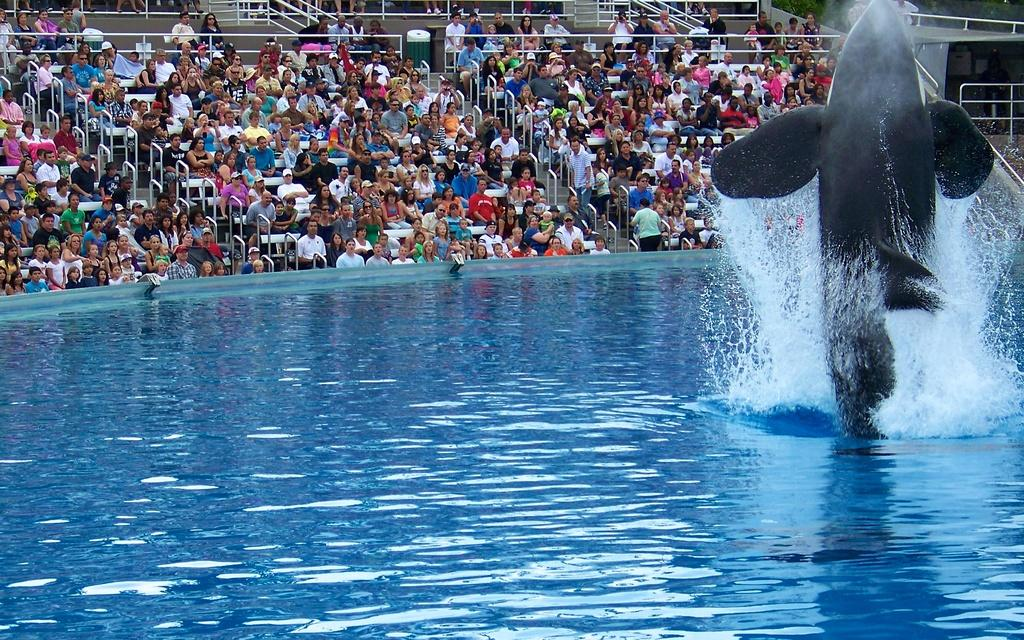What animal can be seen on the right side of the image? There is a dolphin on the right side of the image. What is present at the bottom of the image? There is water at the bottom of the image. What can be seen in the background of the image? There is a crowd, railings, tables, and trees visible in the background of the image. What type of friction can be observed between the dolphin and the water in the image? There is no friction between the dolphin and the water in the image, as dolphins are adapted to move smoothly in water. How many men are present in the image? There is no specific mention of men in the image, so it cannot be determined how many are present. 